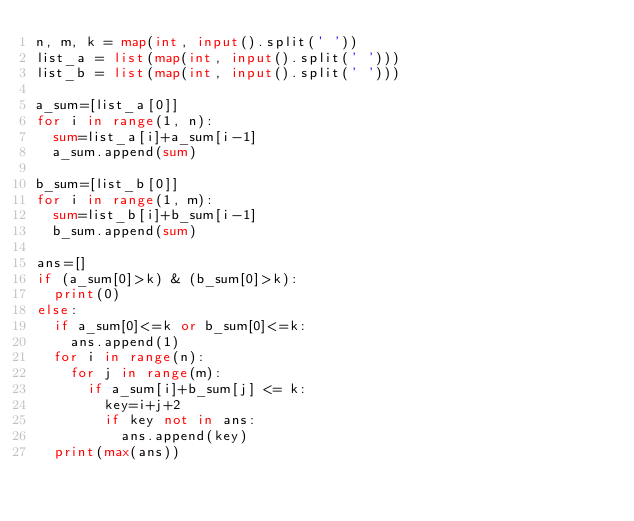<code> <loc_0><loc_0><loc_500><loc_500><_Python_>n, m, k = map(int, input().split(' '))
list_a = list(map(int, input().split(' ')))
list_b = list(map(int, input().split(' ')))

a_sum=[list_a[0]]
for i in range(1, n):
  sum=list_a[i]+a_sum[i-1]
  a_sum.append(sum)
  
b_sum=[list_b[0]]
for i in range(1, m):
  sum=list_b[i]+b_sum[i-1]
  b_sum.append(sum)
  
ans=[]
if (a_sum[0]>k) & (b_sum[0]>k):
  print(0)
else:
  if a_sum[0]<=k or b_sum[0]<=k:
    ans.append(1)
  for i in range(n):
    for j in range(m):
      if a_sum[i]+b_sum[j] <= k:
        key=i+j+2
        if key not in ans:
          ans.append(key)
  print(max(ans))</code> 